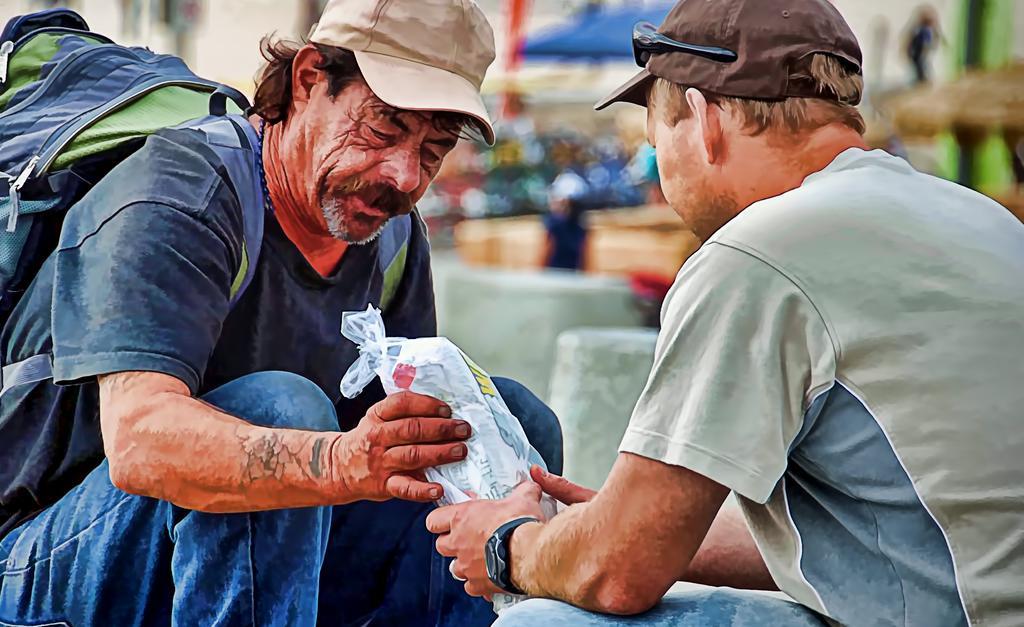Could you give a brief overview of what you see in this image? In the image we can see two men sitting, wearing clothes and a cap. This person is carrying a bag on his back, this is a wrist watch and a plastic cover, these are the goggles. The background is blurred. 